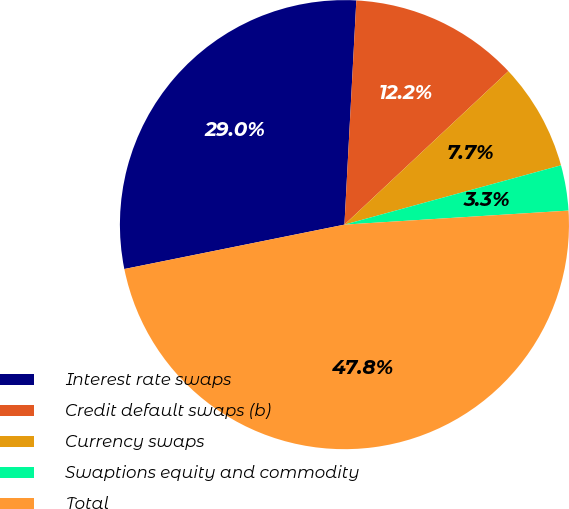Convert chart. <chart><loc_0><loc_0><loc_500><loc_500><pie_chart><fcel>Interest rate swaps<fcel>Credit default swaps (b)<fcel>Currency swaps<fcel>Swaptions equity and commodity<fcel>Total<nl><fcel>29.01%<fcel>12.18%<fcel>7.72%<fcel>3.26%<fcel>47.83%<nl></chart> 